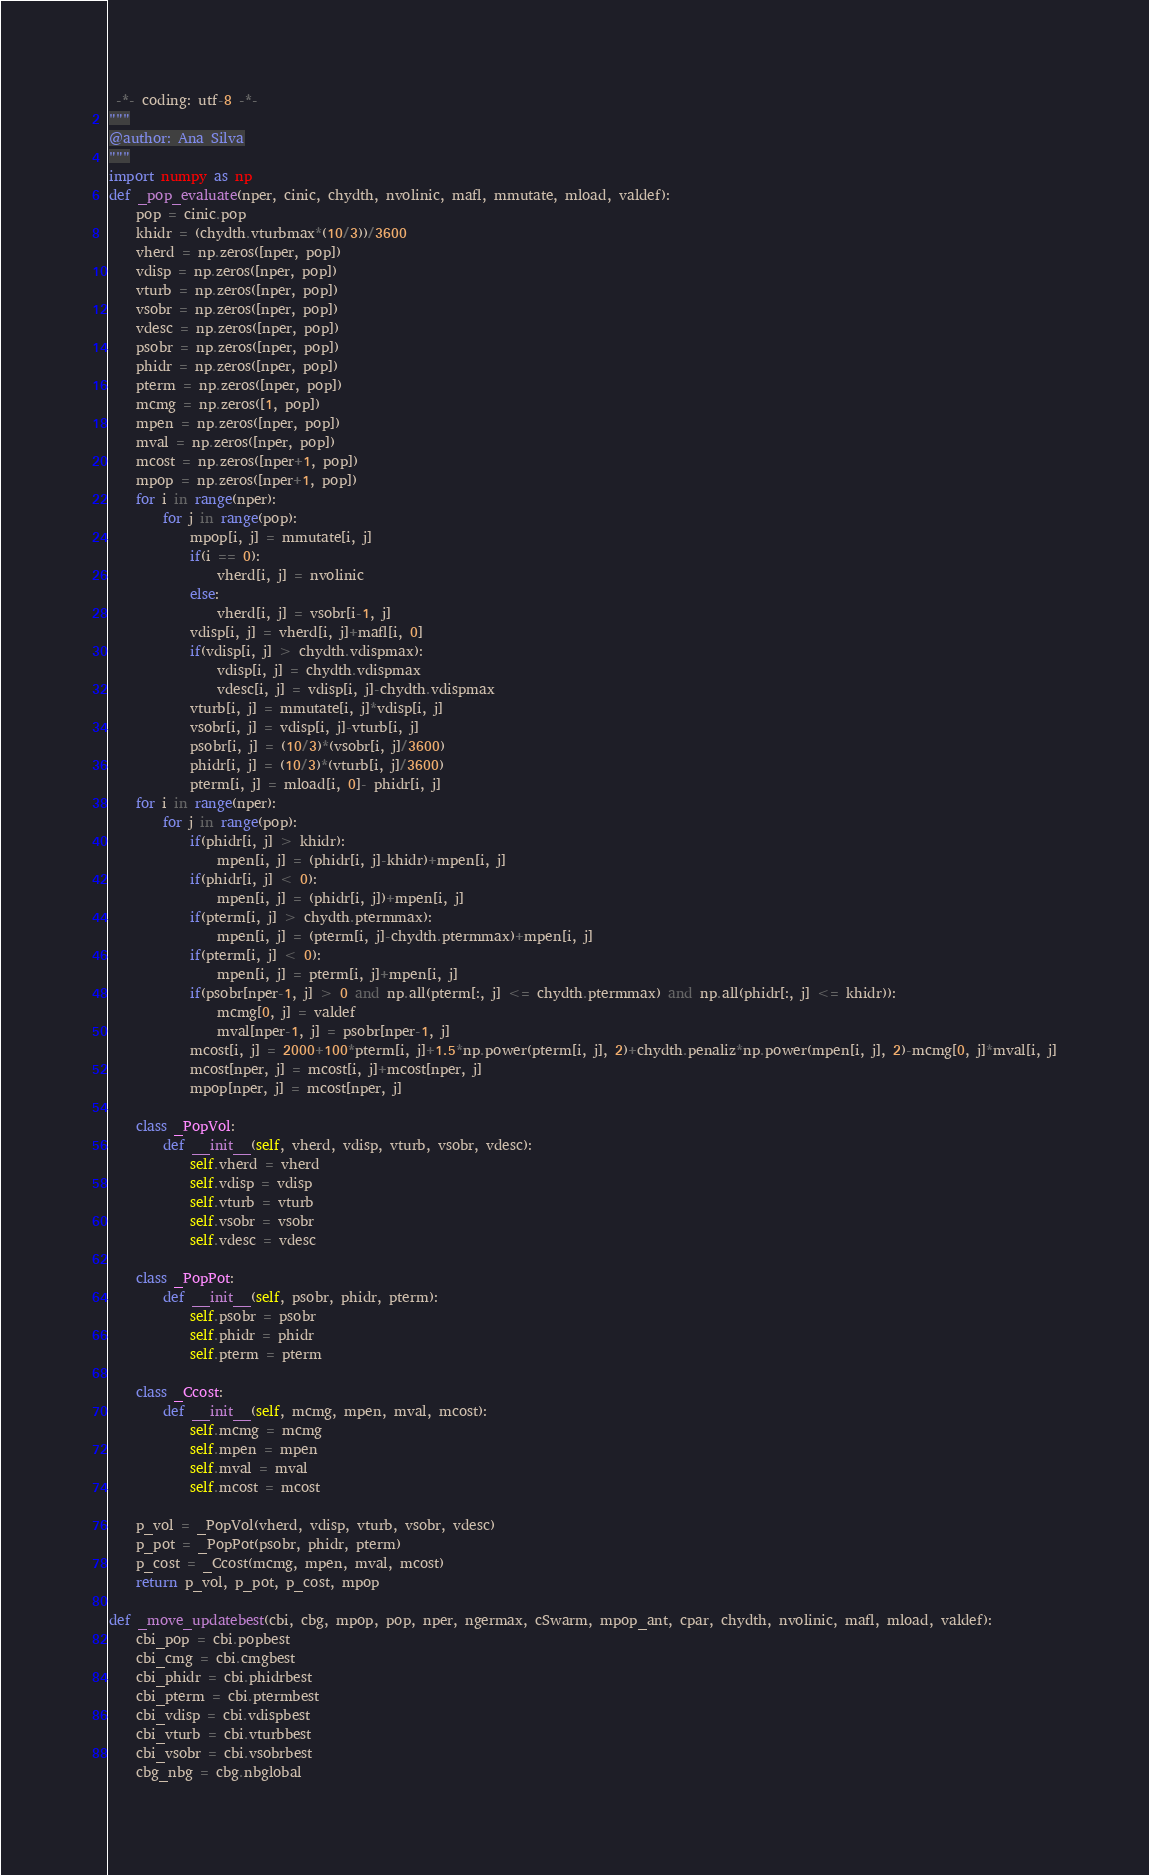<code> <loc_0><loc_0><loc_500><loc_500><_Python_> -*- coding: utf-8 -*-
"""
@author: Ana Silva
"""
import numpy as np
def _pop_evaluate(nper, cinic, chydth, nvolinic, mafl, mmutate, mload, valdef):
    pop = cinic.pop
    khidr = (chydth.vturbmax*(10/3))/3600
    vherd = np.zeros([nper, pop])
    vdisp = np.zeros([nper, pop])
    vturb = np.zeros([nper, pop])
    vsobr = np.zeros([nper, pop])
    vdesc = np.zeros([nper, pop])
    psobr = np.zeros([nper, pop])
    phidr = np.zeros([nper, pop])
    pterm = np.zeros([nper, pop])
    mcmg = np.zeros([1, pop])
    mpen = np.zeros([nper, pop])
    mval = np.zeros([nper, pop])
    mcost = np.zeros([nper+1, pop])
    mpop = np.zeros([nper+1, pop])
    for i in range(nper):
        for j in range(pop):
            mpop[i, j] = mmutate[i, j]
            if(i == 0):
                vherd[i, j] = nvolinic
            else:
                vherd[i, j] = vsobr[i-1, j]
            vdisp[i, j] = vherd[i, j]+mafl[i, 0]
            if(vdisp[i, j] > chydth.vdispmax):
                vdisp[i, j] = chydth.vdispmax
                vdesc[i, j] = vdisp[i, j]-chydth.vdispmax
            vturb[i, j] = mmutate[i, j]*vdisp[i, j]
            vsobr[i, j] = vdisp[i, j]-vturb[i, j]
            psobr[i, j] = (10/3)*(vsobr[i, j]/3600)
            phidr[i, j] = (10/3)*(vturb[i, j]/3600)
            pterm[i, j] = mload[i, 0]- phidr[i, j]
    for i in range(nper):
        for j in range(pop):
            if(phidr[i, j] > khidr):
                mpen[i, j] = (phidr[i, j]-khidr)+mpen[i, j]
            if(phidr[i, j] < 0):
                mpen[i, j] = (phidr[i, j])+mpen[i, j]
            if(pterm[i, j] > chydth.ptermmax):
                mpen[i, j] = (pterm[i, j]-chydth.ptermmax)+mpen[i, j]
            if(pterm[i, j] < 0):
                mpen[i, j] = pterm[i, j]+mpen[i, j]
            if(psobr[nper-1, j] > 0 and np.all(pterm[:, j] <= chydth.ptermmax) and np.all(phidr[:, j] <= khidr)):
                mcmg[0, j] = valdef
                mval[nper-1, j] = psobr[nper-1, j]
            mcost[i, j] = 2000+100*pterm[i, j]+1.5*np.power(pterm[i, j], 2)+chydth.penaliz*np.power(mpen[i, j], 2)-mcmg[0, j]*mval[i, j]
            mcost[nper, j] = mcost[i, j]+mcost[nper, j]
            mpop[nper, j] = mcost[nper, j]
            
    class _PopVol:
        def __init__(self, vherd, vdisp, vturb, vsobr, vdesc):
            self.vherd = vherd
            self.vdisp = vdisp
            self.vturb = vturb
            self.vsobr = vsobr
            self.vdesc = vdesc
            
    class _PopPot:
        def __init__(self, psobr, phidr, pterm):
            self.psobr = psobr 
            self.phidr = phidr
            self.pterm = pterm
            
    class _Ccost:
        def __init__(self, mcmg, mpen, mval, mcost):
            self.mcmg = mcmg
            self.mpen = mpen
            self.mval = mval
            self.mcost = mcost
            
    p_vol = _PopVol(vherd, vdisp, vturb, vsobr, vdesc)
    p_pot = _PopPot(psobr, phidr, pterm)
    p_cost = _Ccost(mcmg, mpen, mval, mcost)  
    return p_vol, p_pot, p_cost, mpop        

def _move_updatebest(cbi, cbg, mpop, pop, nper, ngermax, cSwarm, mpop_ant, cpar, chydth, nvolinic, mafl, mload, valdef):
    cbi_pop = cbi.popbest
    cbi_cmg = cbi.cmgbest
    cbi_phidr = cbi.phidrbest
    cbi_pterm = cbi.ptermbest
    cbi_vdisp = cbi.vdispbest
    cbi_vturb = cbi.vturbbest
    cbi_vsobr = cbi.vsobrbest
    cbg_nbg = cbg.nbglobal</code> 